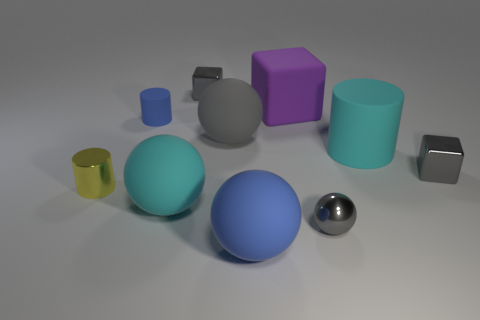Subtract all large spheres. How many spheres are left? 1 Subtract all brown blocks. How many gray balls are left? 2 Subtract all gray balls. How many balls are left? 2 Subtract all balls. How many objects are left? 6 Subtract 1 purple blocks. How many objects are left? 9 Subtract 3 balls. How many balls are left? 1 Subtract all cyan cubes. Subtract all purple balls. How many cubes are left? 3 Subtract all large cyan objects. Subtract all tiny balls. How many objects are left? 7 Add 1 blue rubber objects. How many blue rubber objects are left? 3 Add 3 small balls. How many small balls exist? 4 